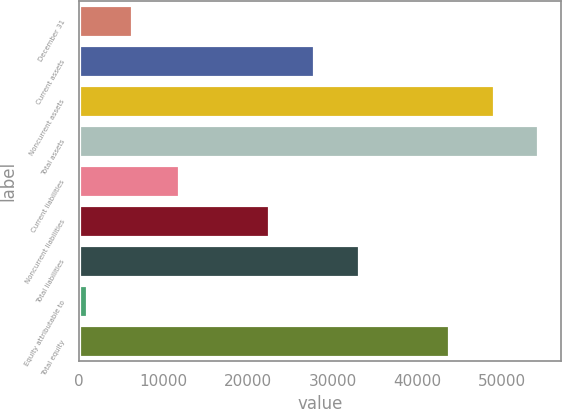<chart> <loc_0><loc_0><loc_500><loc_500><bar_chart><fcel>December 31<fcel>Current assets<fcel>Noncurrent assets<fcel>Total assets<fcel>Current liabilities<fcel>Noncurrent liabilities<fcel>Total liabilities<fcel>Equity attributable to<fcel>Total equity<nl><fcel>6195.1<fcel>27762.3<fcel>49018.7<fcel>54332.8<fcel>11820<fcel>22448.2<fcel>33076.4<fcel>881<fcel>43704.6<nl></chart> 